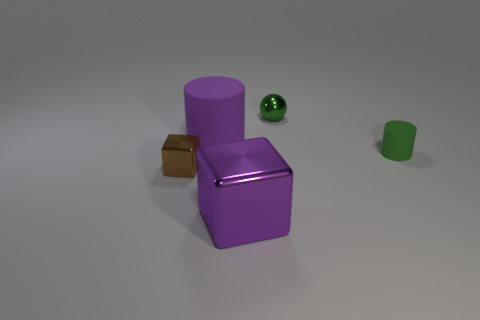What materials do the objects in the image appear to be made of? The objects in the image have a smooth, somewhat reflective surface which suggests they could be made of materials like plastic or perhaps a coated metal. 